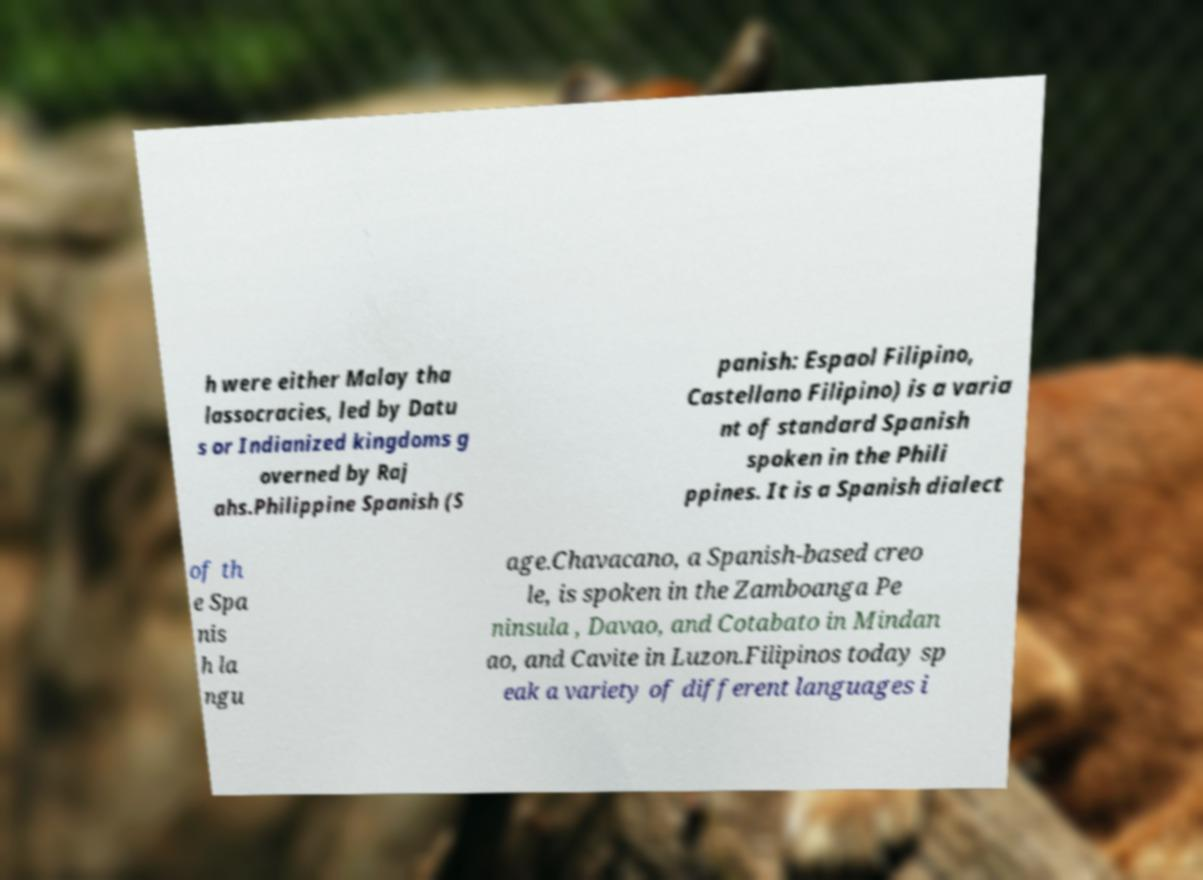There's text embedded in this image that I need extracted. Can you transcribe it verbatim? h were either Malay tha lassocracies, led by Datu s or Indianized kingdoms g overned by Raj ahs.Philippine Spanish (S panish: Espaol Filipino, Castellano Filipino) is a varia nt of standard Spanish spoken in the Phili ppines. It is a Spanish dialect of th e Spa nis h la ngu age.Chavacano, a Spanish-based creo le, is spoken in the Zamboanga Pe ninsula , Davao, and Cotabato in Mindan ao, and Cavite in Luzon.Filipinos today sp eak a variety of different languages i 